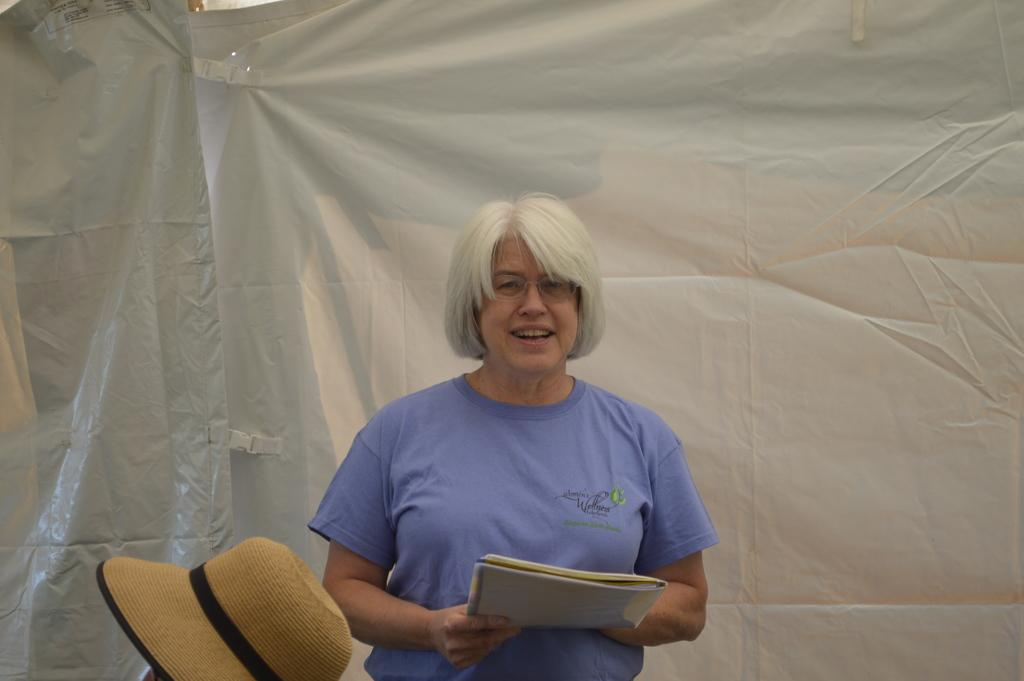What is the person in the image doing? The person is standing in the image and holding a book. What object is visible in the image besides the person and the book? There is a hat in the image. What can be seen in the background of the image? There are tarpaulin covers or sheets in the background of the image. What type of health advice is the person giving in the image? There is no indication in the image that the person is giving health advice, as the focus is on the person holding a book and the presence of a hat and tarpaulin covers in the background. 